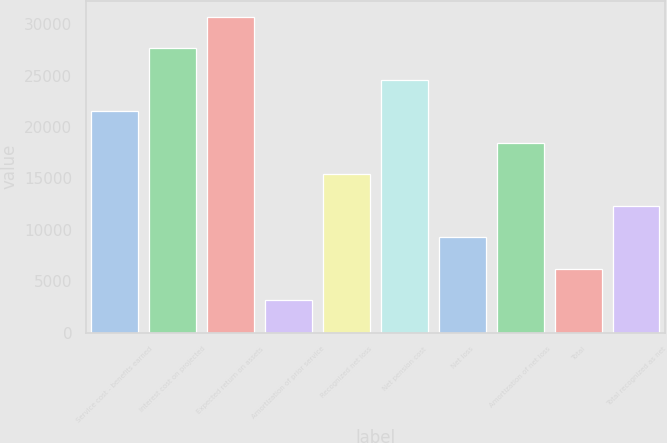Convert chart. <chart><loc_0><loc_0><loc_500><loc_500><bar_chart><fcel>Service cost - benefits earned<fcel>Interest cost on projected<fcel>Expected return on assets<fcel>Amortization of prior service<fcel>Recognized net loss<fcel>Net pension cost<fcel>Net loss<fcel>Amortization of net loss<fcel>Total<fcel>Total recognized as net<nl><fcel>21550.1<fcel>27684.7<fcel>30752<fcel>3146.3<fcel>15415.5<fcel>24617.4<fcel>9280.9<fcel>18482.8<fcel>6213.6<fcel>12348.2<nl></chart> 